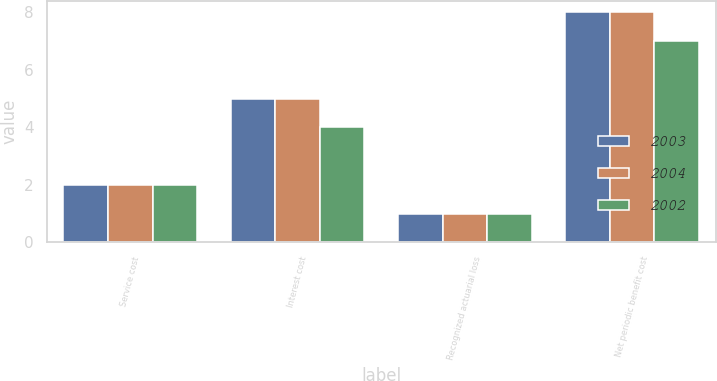<chart> <loc_0><loc_0><loc_500><loc_500><stacked_bar_chart><ecel><fcel>Service cost<fcel>Interest cost<fcel>Recognized actuarial loss<fcel>Net periodic benefit cost<nl><fcel>2003<fcel>2<fcel>5<fcel>1<fcel>8<nl><fcel>2004<fcel>2<fcel>5<fcel>1<fcel>8<nl><fcel>2002<fcel>2<fcel>4<fcel>1<fcel>7<nl></chart> 